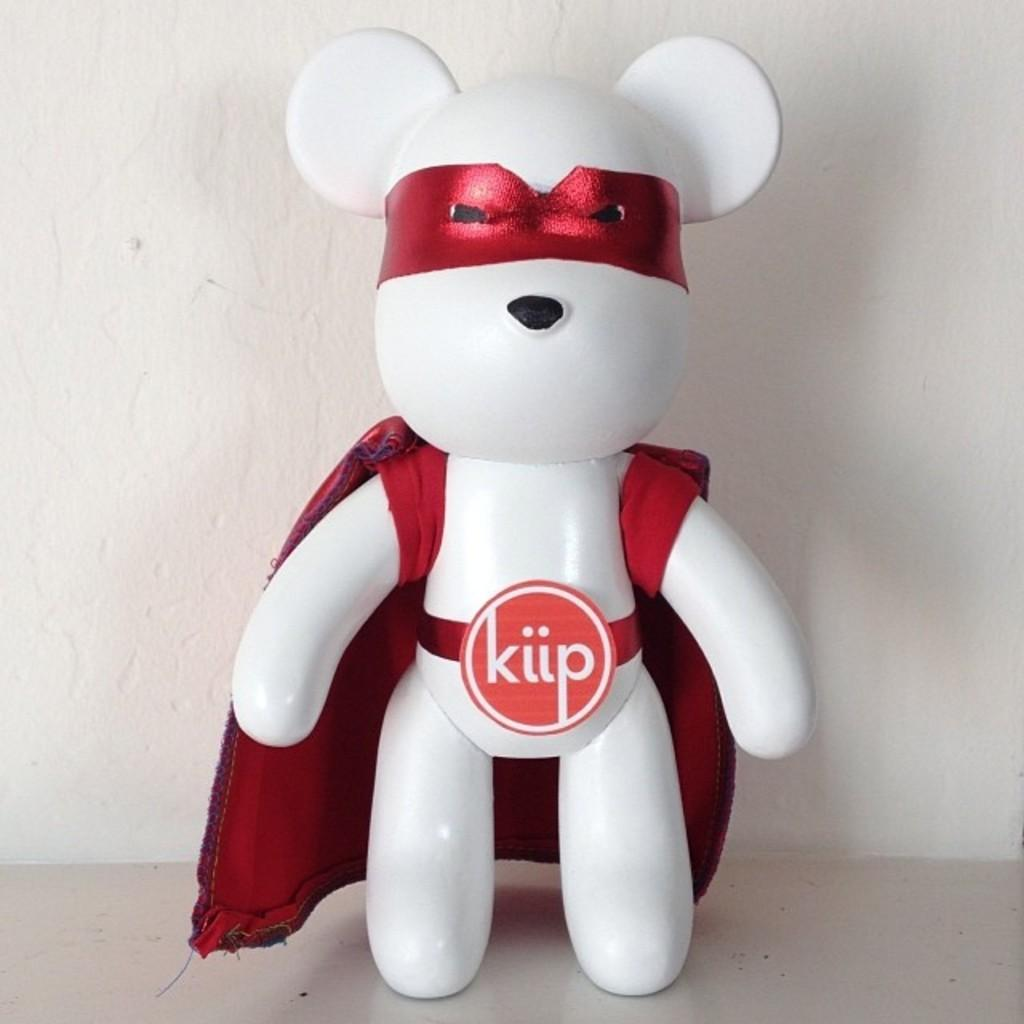What is on the floor in the image? There is a toy on the floor in the image. What can be seen in the background of the image? There is a wall visible in the image. Can you describe the setting of the image? The image may have been taken in a room, as there is a floor and a wall present. What type of lettuce is being used as a cloth to clean the toy in the image? There is no lettuce or cloth present in the image, and the toy is not being cleaned. 